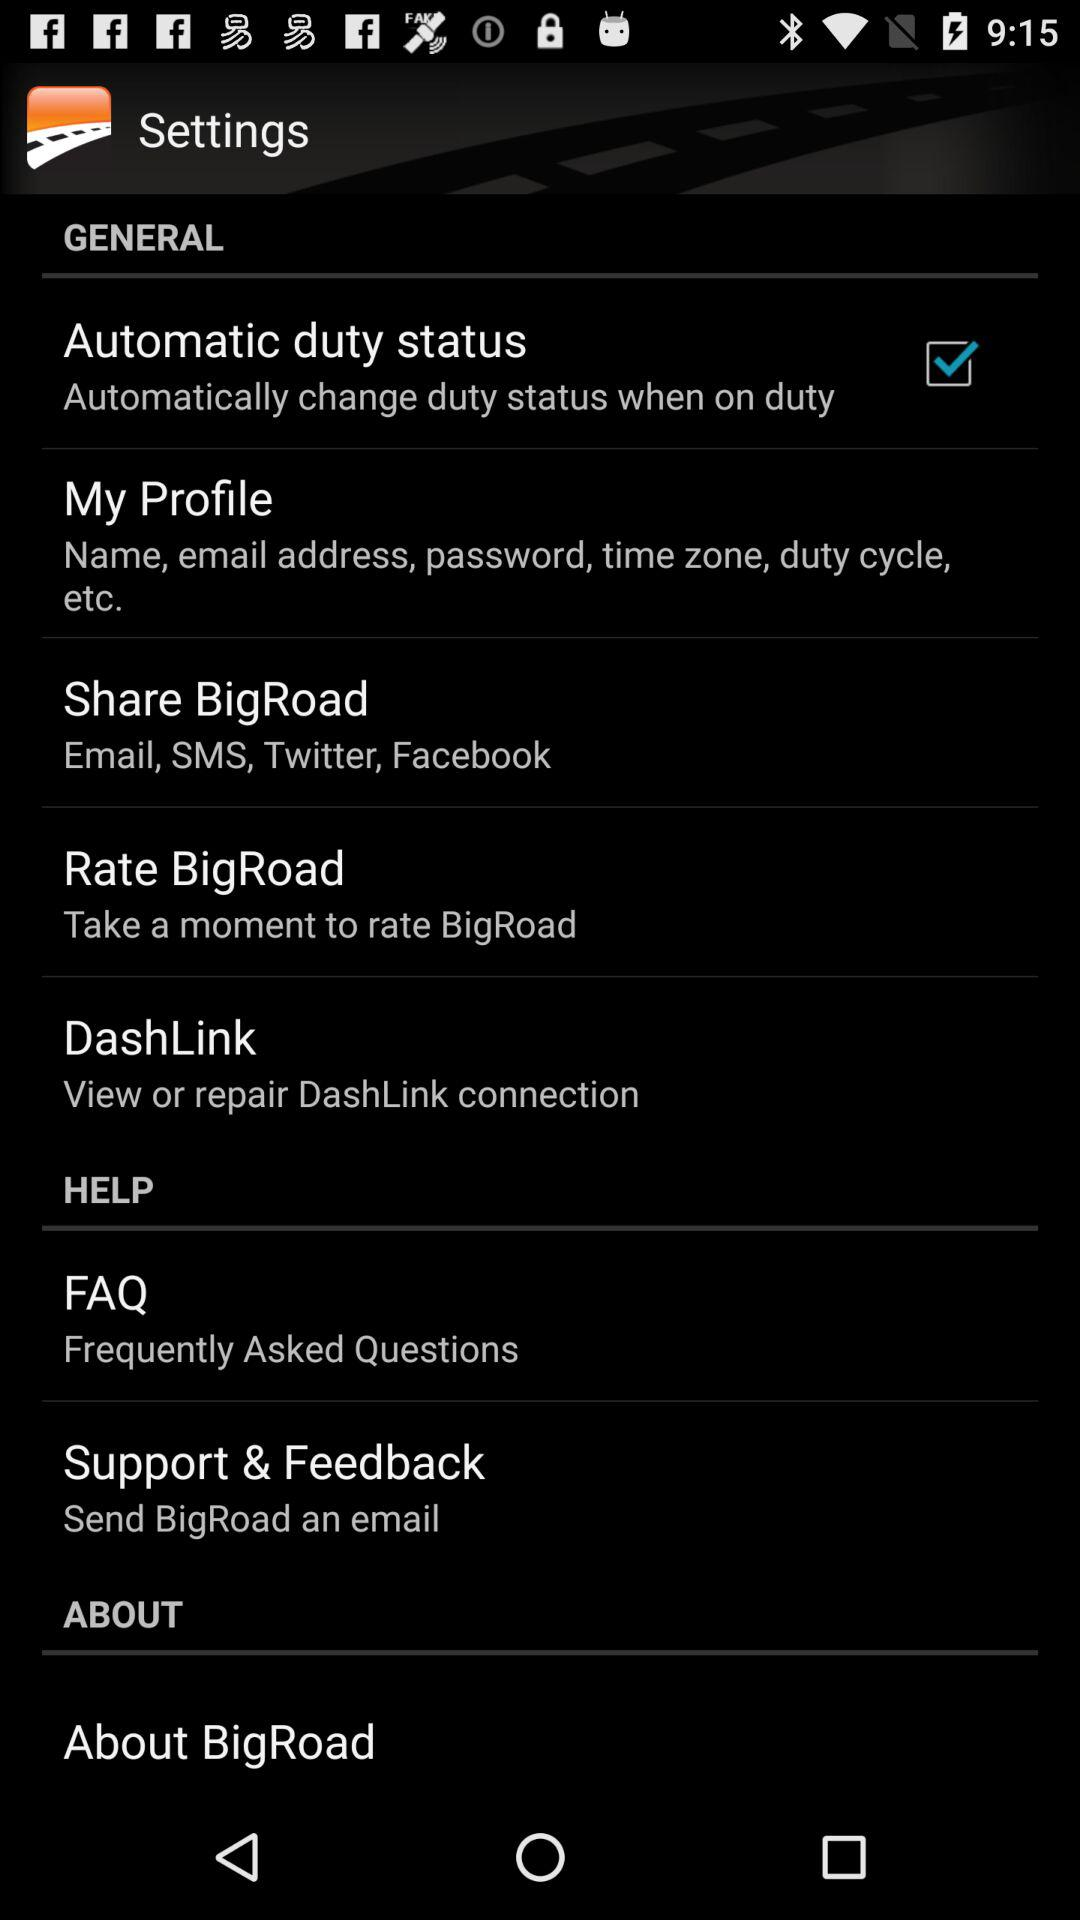What is the name of the application? The name of the application is "BigRoad". 